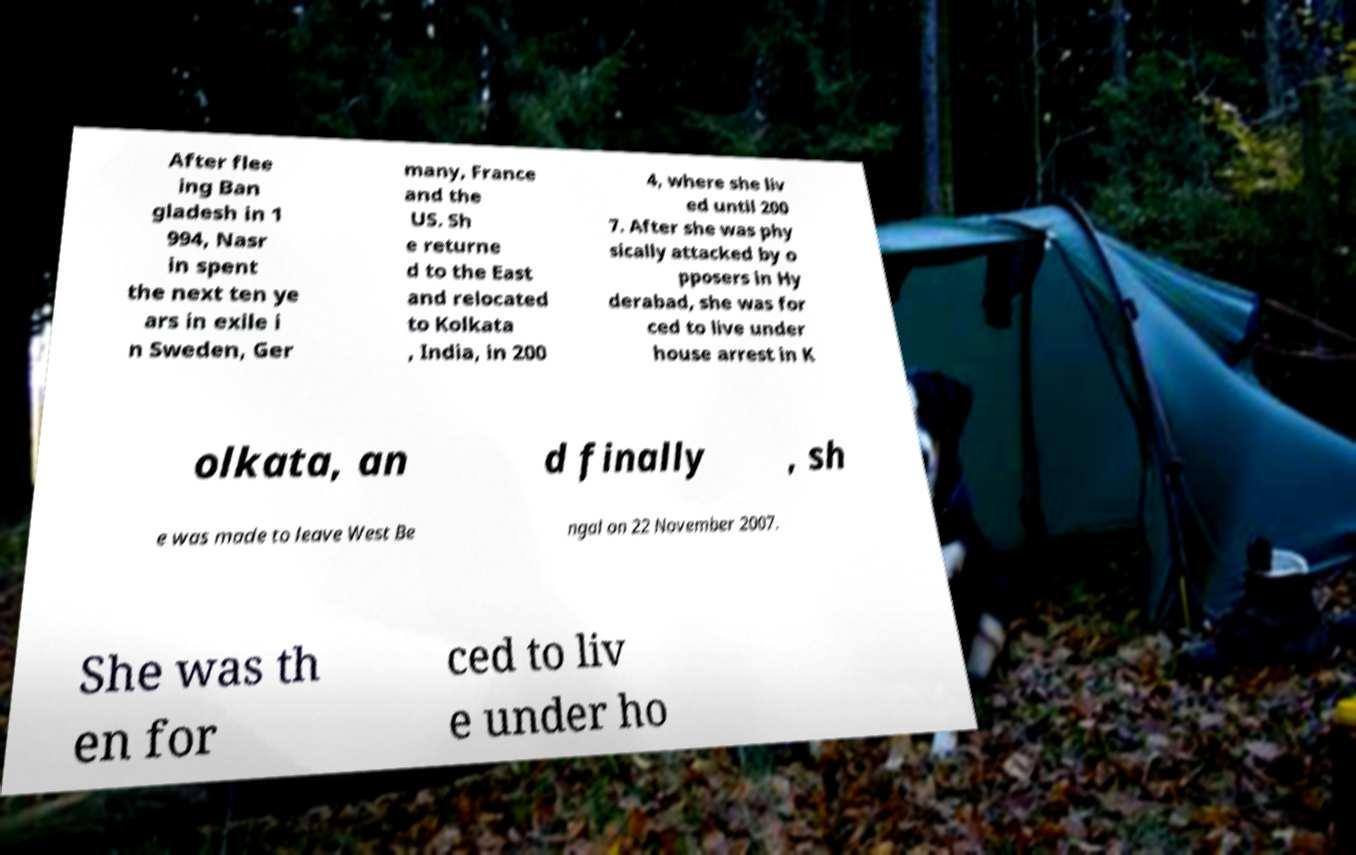Could you extract and type out the text from this image? After flee ing Ban gladesh in 1 994, Nasr in spent the next ten ye ars in exile i n Sweden, Ger many, France and the US. Sh e returne d to the East and relocated to Kolkata , India, in 200 4, where she liv ed until 200 7. After she was phy sically attacked by o pposers in Hy derabad, she was for ced to live under house arrest in K olkata, an d finally , sh e was made to leave West Be ngal on 22 November 2007. She was th en for ced to liv e under ho 